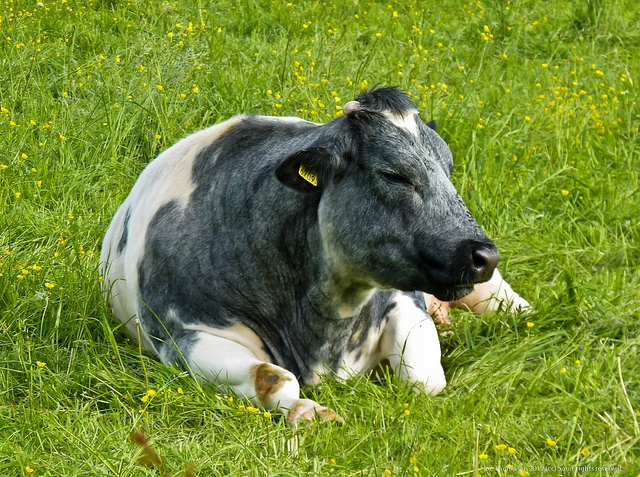Describe the objects in this image and their specific colors. I can see a cow in olive, black, gray, lightgray, and darkgray tones in this image. 